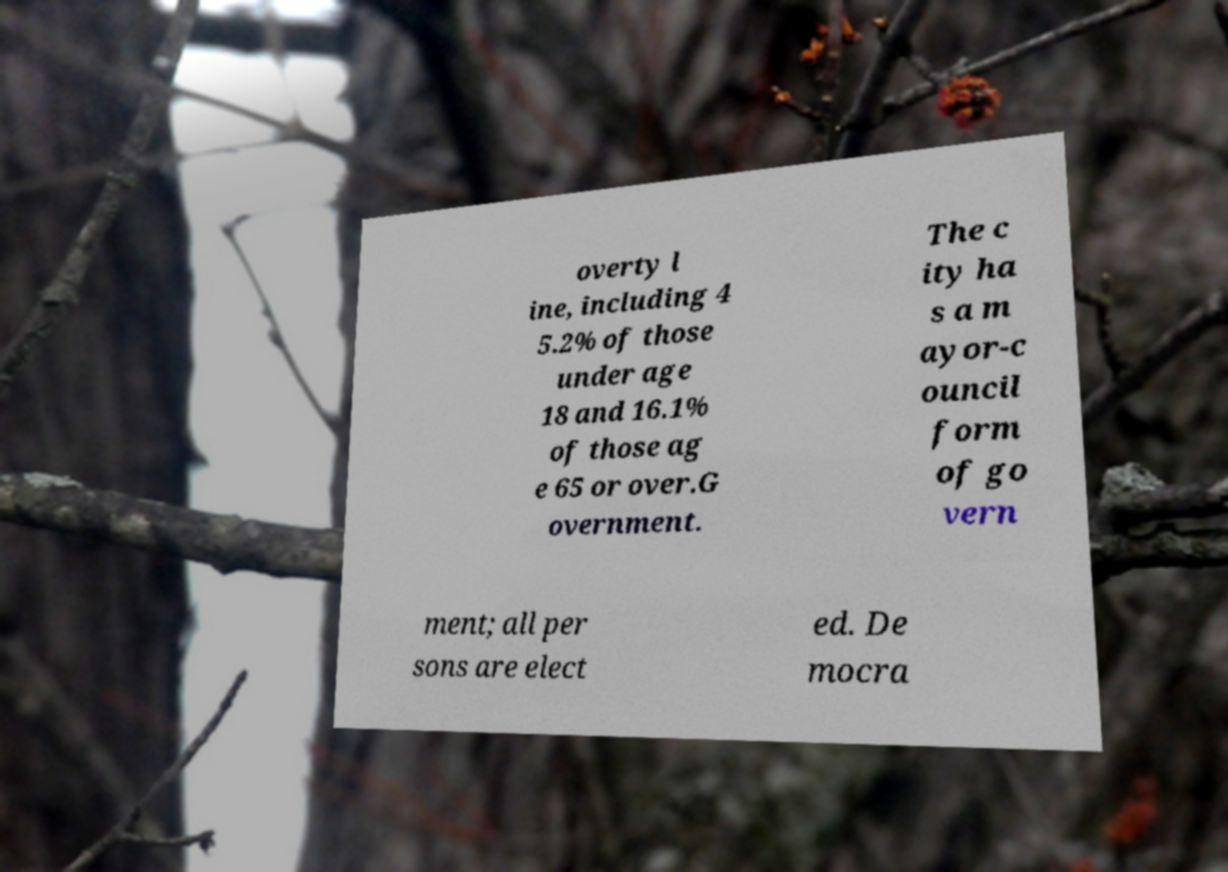Please identify and transcribe the text found in this image. overty l ine, including 4 5.2% of those under age 18 and 16.1% of those ag e 65 or over.G overnment. The c ity ha s a m ayor-c ouncil form of go vern ment; all per sons are elect ed. De mocra 